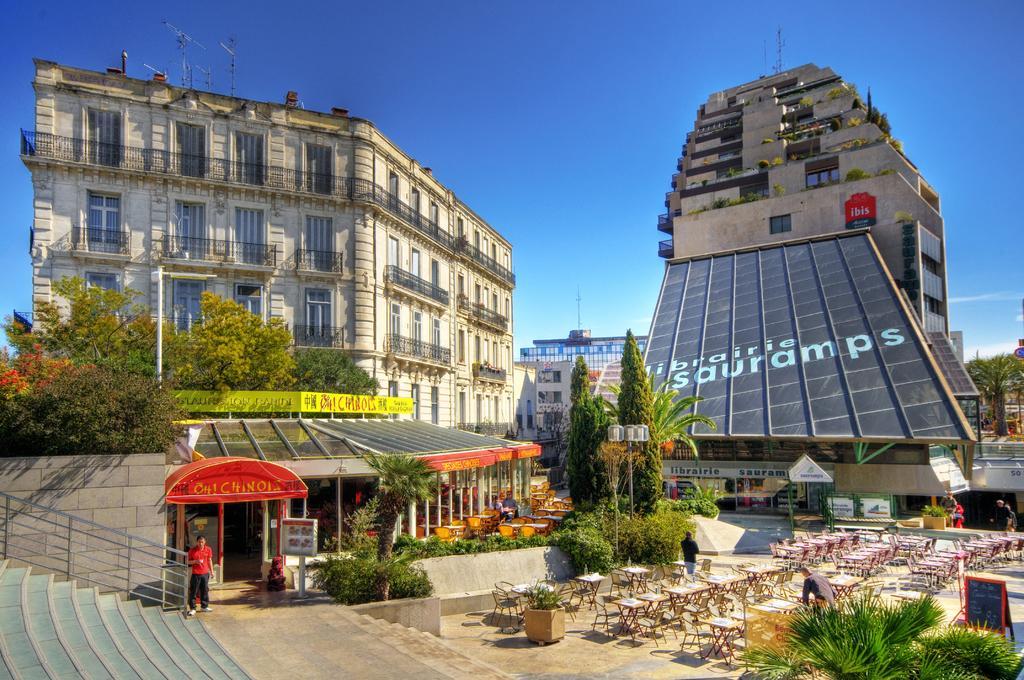In one or two sentences, can you explain what this image depicts? In this image, we can see buildings, trees, stairs, chairs and tables, poles, name boards and sign boards and some flower pots. At the top, there is sky. 